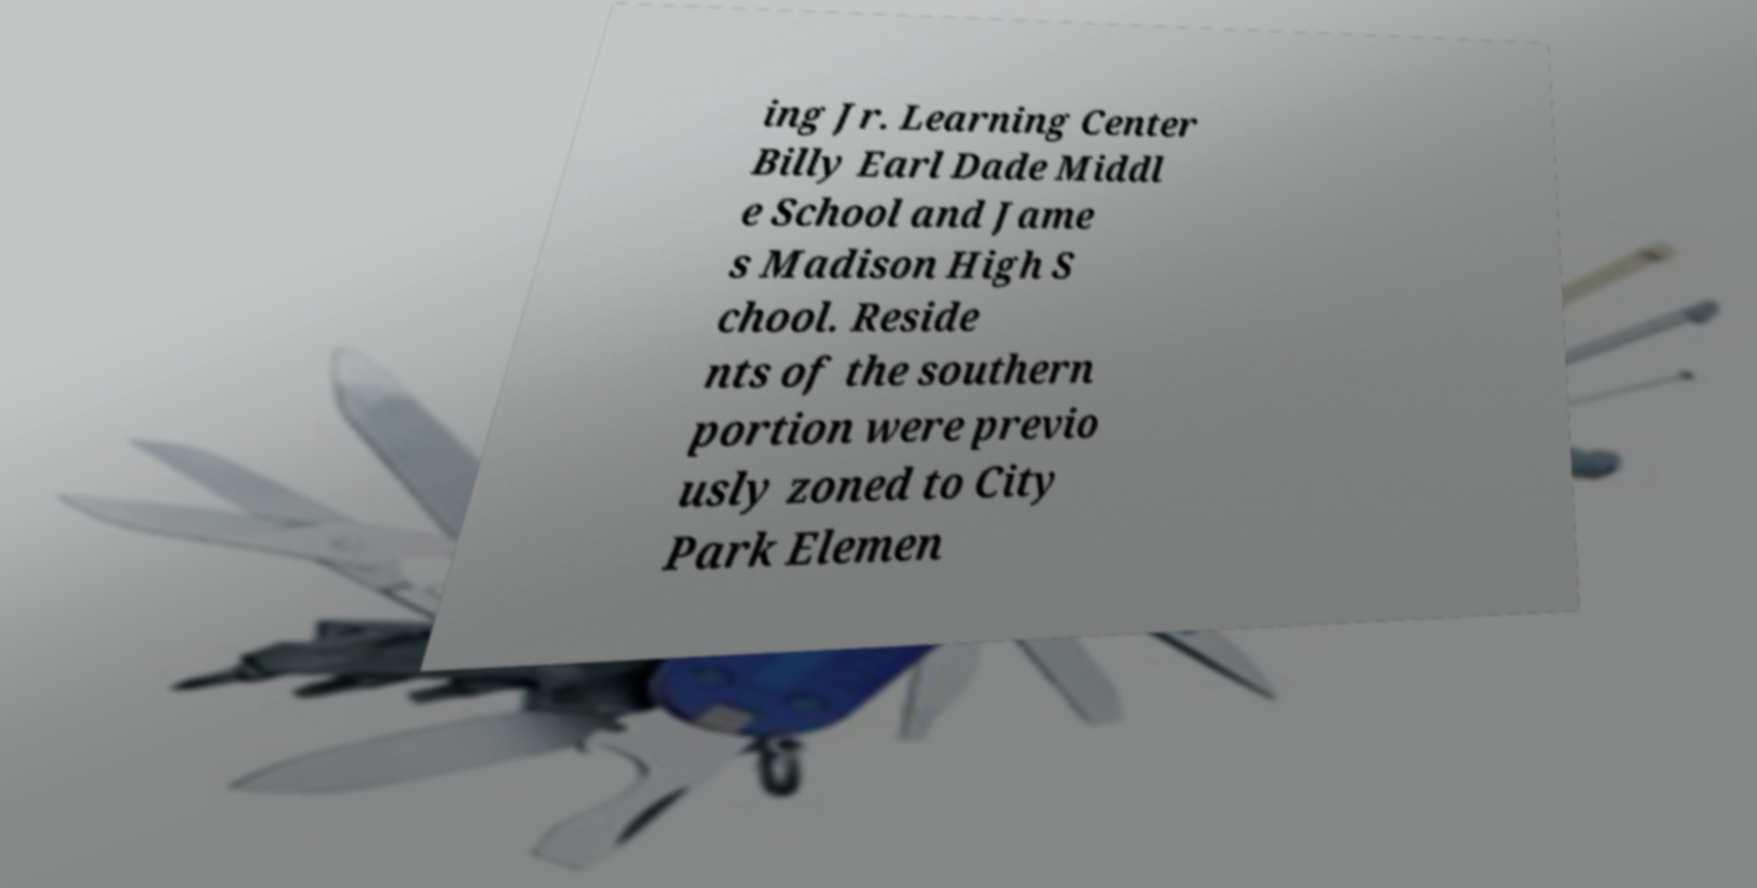Can you read and provide the text displayed in the image?This photo seems to have some interesting text. Can you extract and type it out for me? ing Jr. Learning Center Billy Earl Dade Middl e School and Jame s Madison High S chool. Reside nts of the southern portion were previo usly zoned to City Park Elemen 